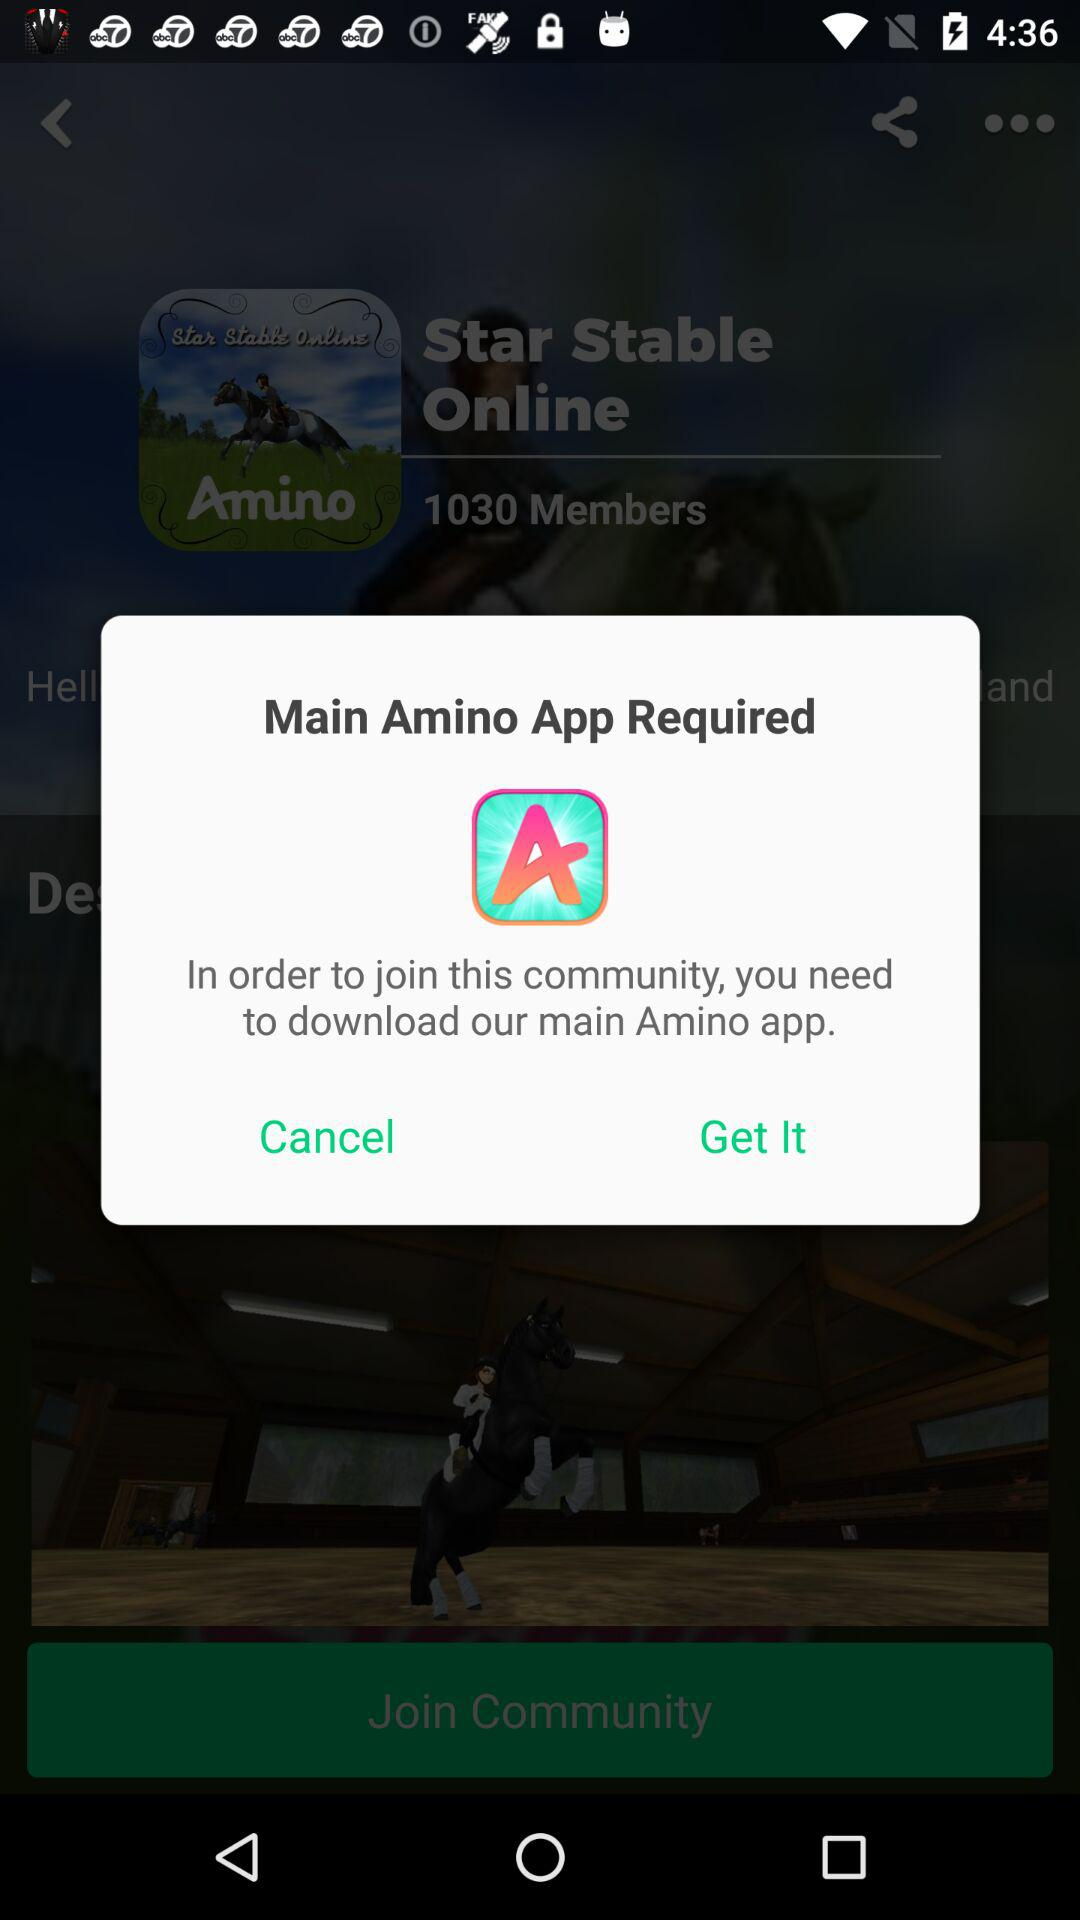What is the application name? The application names are "Star Stable Online" and "Amino: Communities and Fandom". 